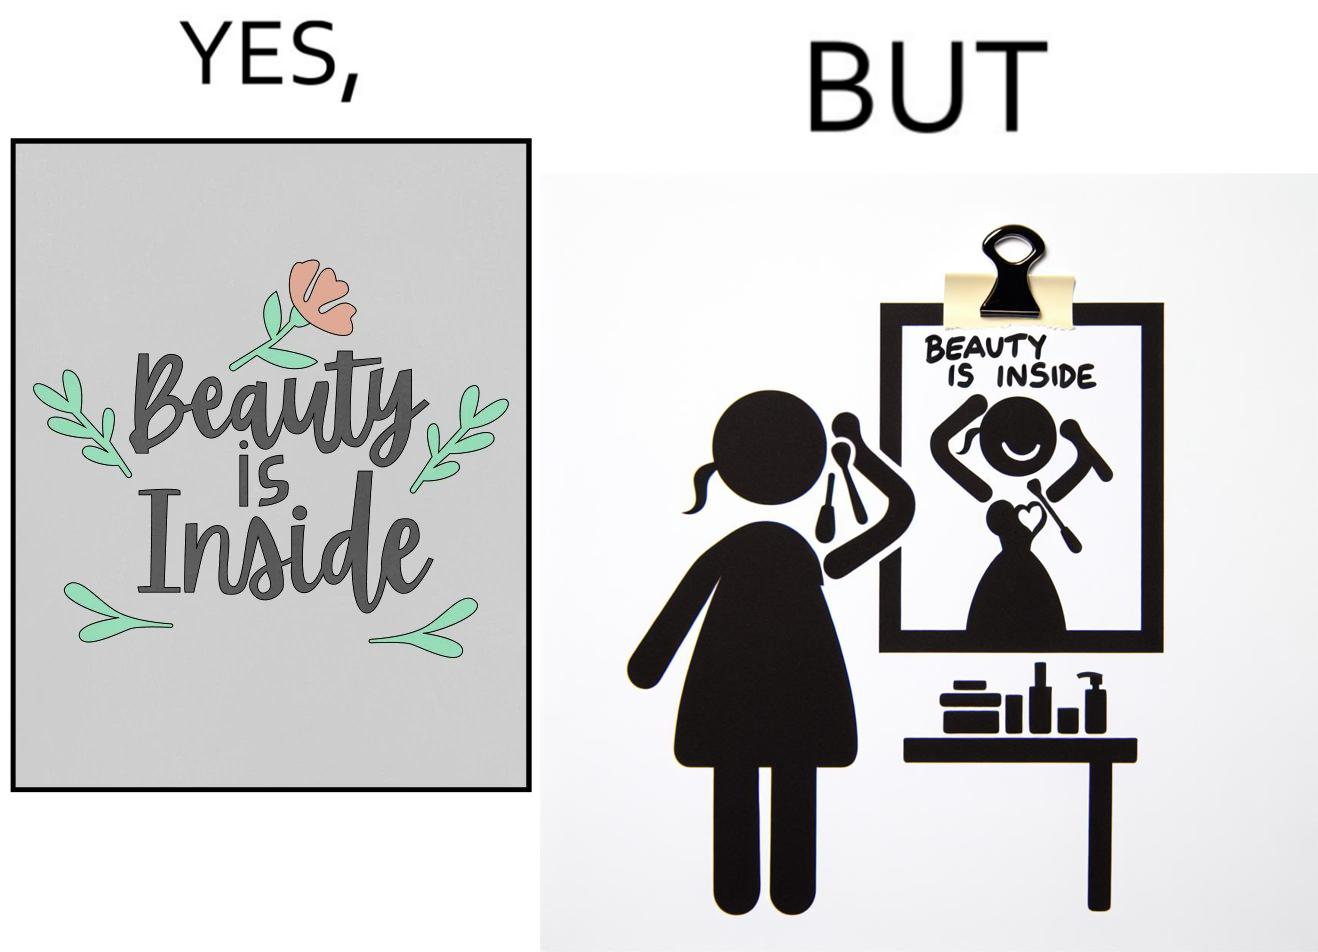What is shown in the left half versus the right half of this image? In the left part of the image: The image shows a text in beautiful font with flowers drawn around it. The text says "Beauty Is Inside". In the right part of the image: The image shows a woman applying makeup after shower by looking at herself in the dressing mirror. A piece of paper that says "Beauty is Inside" is clipped to the top of the mirror. 